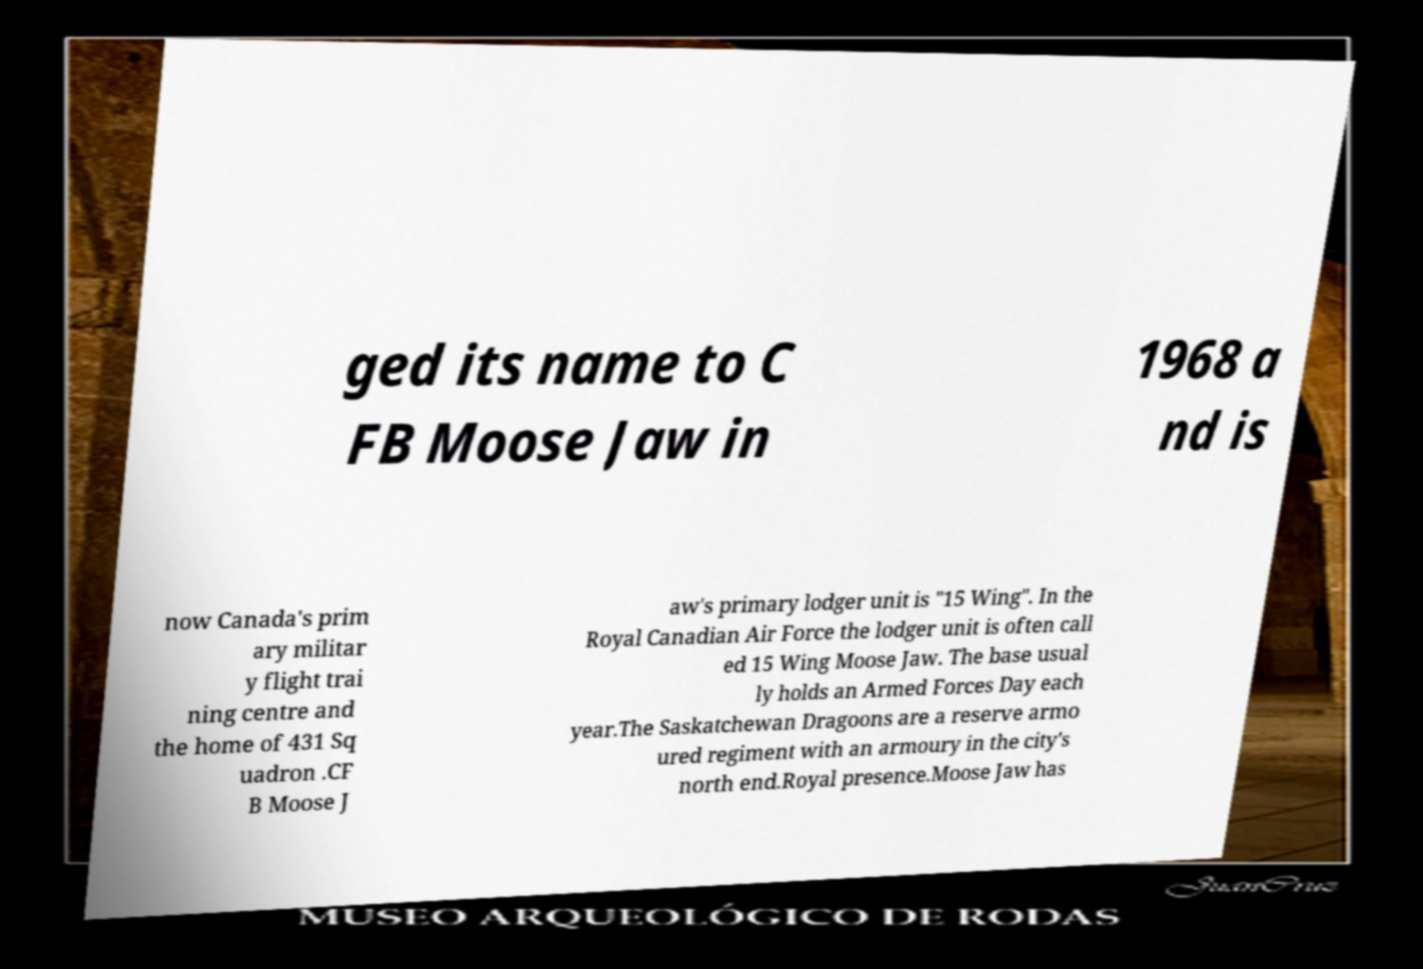I need the written content from this picture converted into text. Can you do that? ged its name to C FB Moose Jaw in 1968 a nd is now Canada's prim ary militar y flight trai ning centre and the home of 431 Sq uadron .CF B Moose J aw's primary lodger unit is "15 Wing". In the Royal Canadian Air Force the lodger unit is often call ed 15 Wing Moose Jaw. The base usual ly holds an Armed Forces Day each year.The Saskatchewan Dragoons are a reserve armo ured regiment with an armoury in the city's north end.Royal presence.Moose Jaw has 